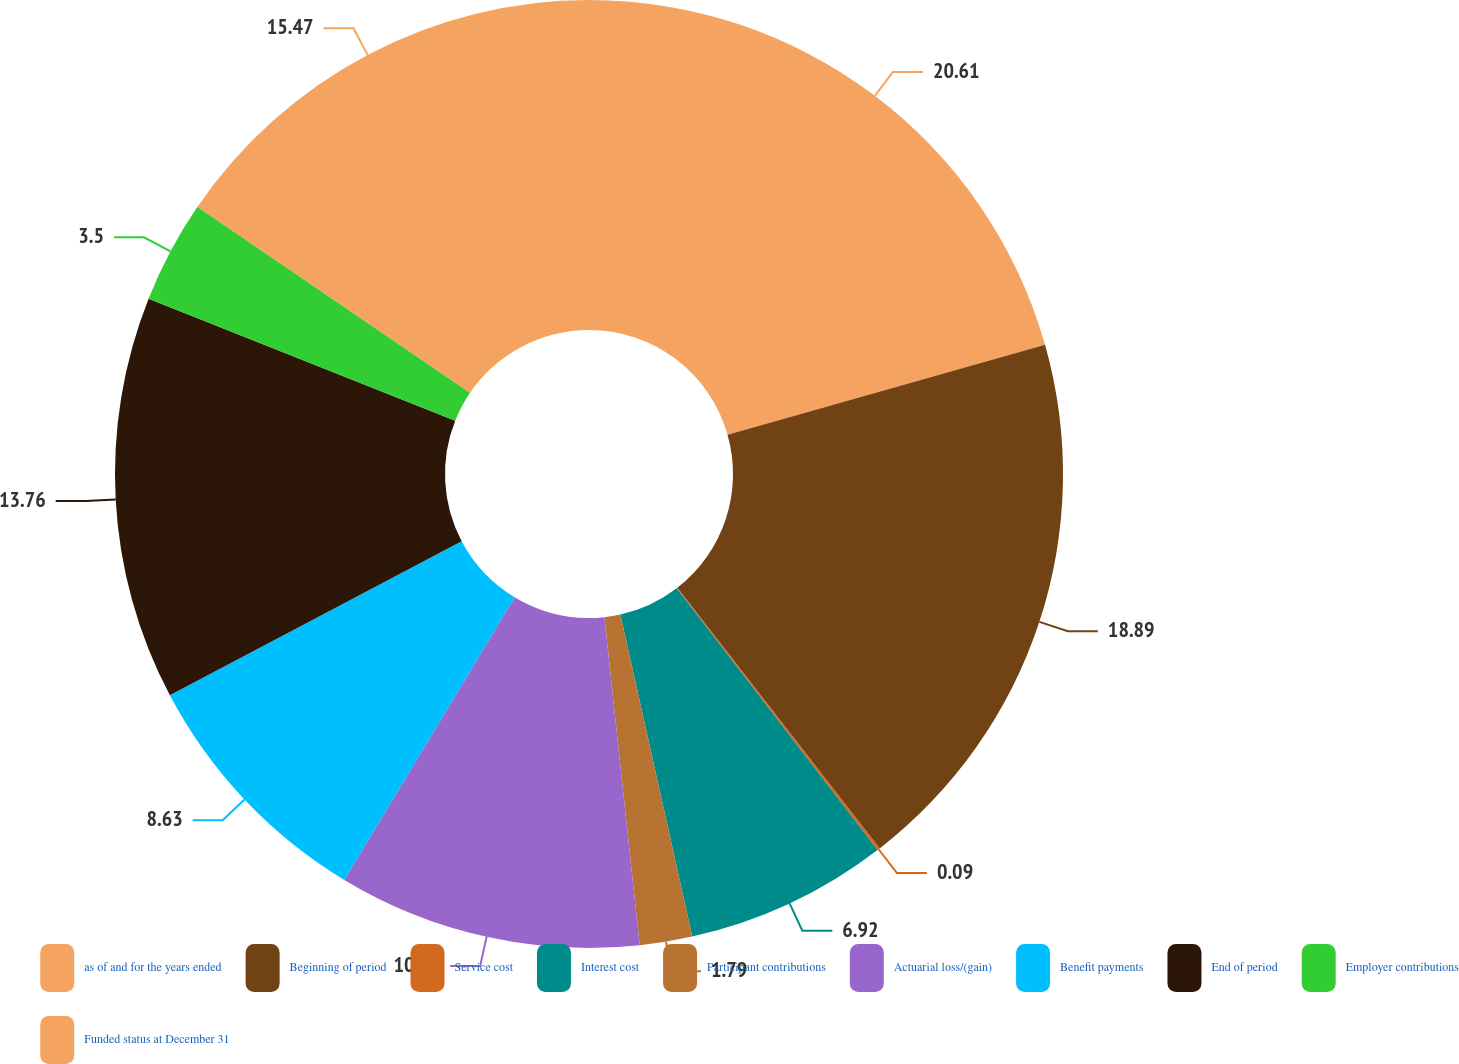Convert chart. <chart><loc_0><loc_0><loc_500><loc_500><pie_chart><fcel>as of and for the years ended<fcel>Beginning of period<fcel>Service cost<fcel>Interest cost<fcel>Participant contributions<fcel>Actuarial loss/(gain)<fcel>Benefit payments<fcel>End of period<fcel>Employer contributions<fcel>Funded status at December 31<nl><fcel>20.6%<fcel>18.89%<fcel>0.09%<fcel>6.92%<fcel>1.79%<fcel>10.34%<fcel>8.63%<fcel>13.76%<fcel>3.5%<fcel>15.47%<nl></chart> 